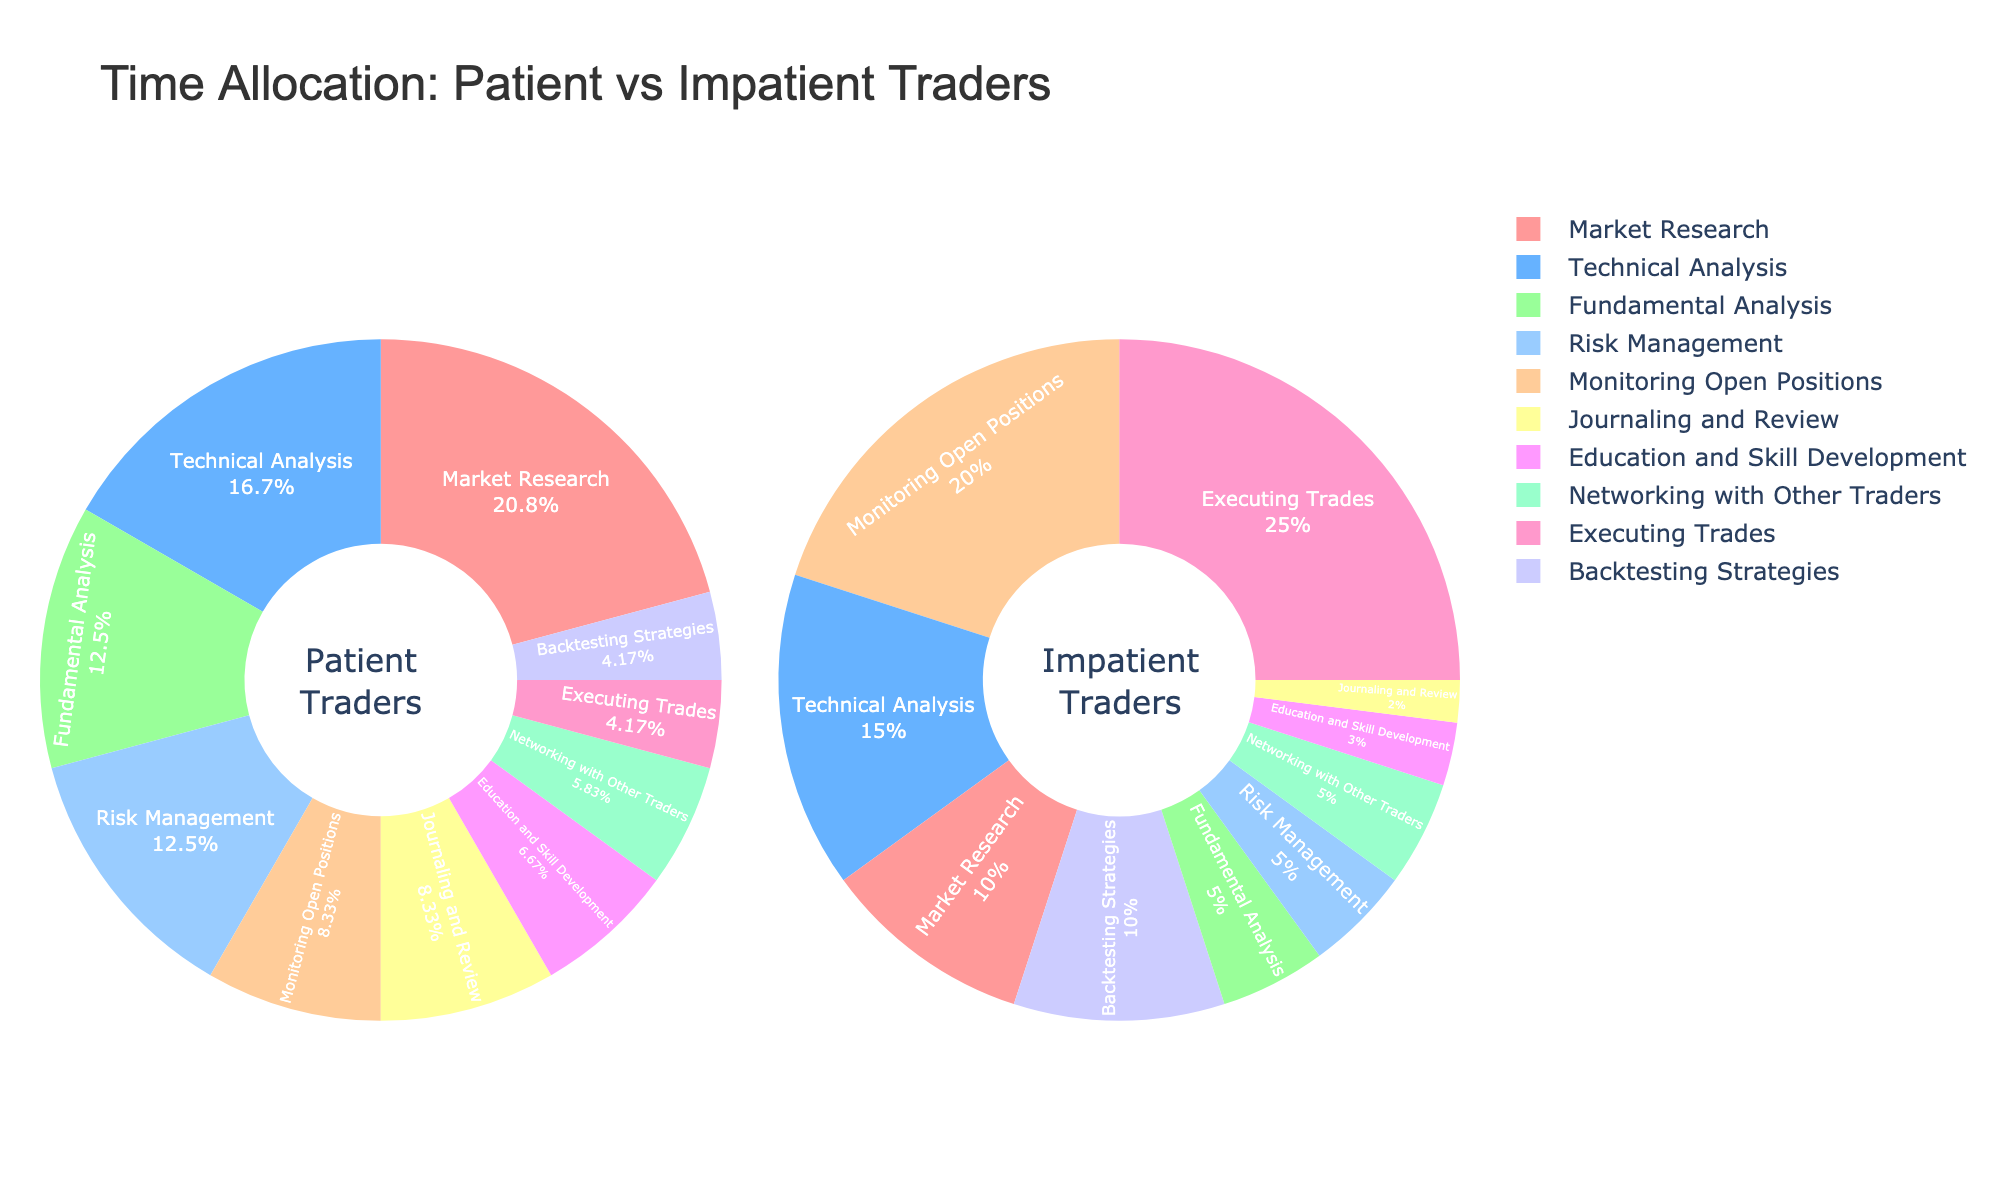What activity do patient traders spend most of their time on? By visual inspection, the largest section of the pie chart for patient traders is labeled "Market Research." This indicates that this is where they spend most of their time, as it occupies 25% of their time.
Answer: Market Research Which activity do impatient traders spend the least time on? By looking at the smallest section of the pie chart for impatient traders, it is labeled as "Journaling and Review." This takes up the smallest percentage of their time, at 2%.
Answer: Journaling and Review How does the time spent on risk management compare between patient and impatient traders? Risk Management takes up 15% of the time for patient traders and 5% for impatient traders, indicated by the pie chart sections. Patient traders spend more time on risk management than impatient traders.
Answer: Patient traders spend more time Calculate the combined percentage of time patient traders spend on education, skill development, and journaling and review. Patient traders spend 10% of their time on Journaling and Review and 8% on Education and Skill Development. Adding these together: 10% + 8% = 18%.
Answer: 18% Which trader group spends a higher percentage of time backtesting strategies? By comparing the sections labeled "Backtesting Strategies" on both pie charts, impatient traders spend 10% of their time while patient traders spend 5%.
Answer: Impatient traders What is the difference in the percentage of time spent on executing trades between the two groups? Patient traders spend 5% of their time on Executing Trades, while impatient traders spend 25%. The difference is 25% - 5% = 20%.
Answer: 20% Compare the time allocation for fundamental analysis between patient and impatient traders. Fundamental Analysis occupies 15% of the time for patient traders and 5% for impatient traders, indicated by the respective sections of the pie charts. Patient traders spend more time in this activity.
Answer: Patient traders spend more time Out of these activities, which one has the most similar time allocation between patient and impatient traders? By comparing the sections across the two pie charts, "Networking with Other Traders" shows similarity. Patient traders spend 7%, and impatient traders spend 5%, a relatively small difference of 2%.
Answer: Networking with Other Traders Is there any activity where both trader groups allocate the same percentage of their time? By examining both pie charts, no activity shows equal time allocation percentages between the two groups. Each activity has a different percentage for patient and impatient traders.
Answer: No 